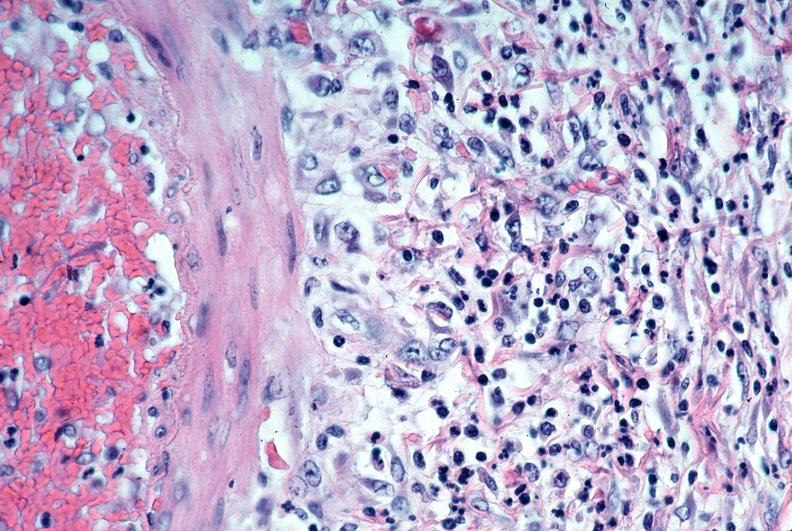s vasculature present?
Answer the question using a single word or phrase. Yes 